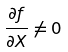Convert formula to latex. <formula><loc_0><loc_0><loc_500><loc_500>\frac { \partial f } { \partial X } \ne 0</formula> 